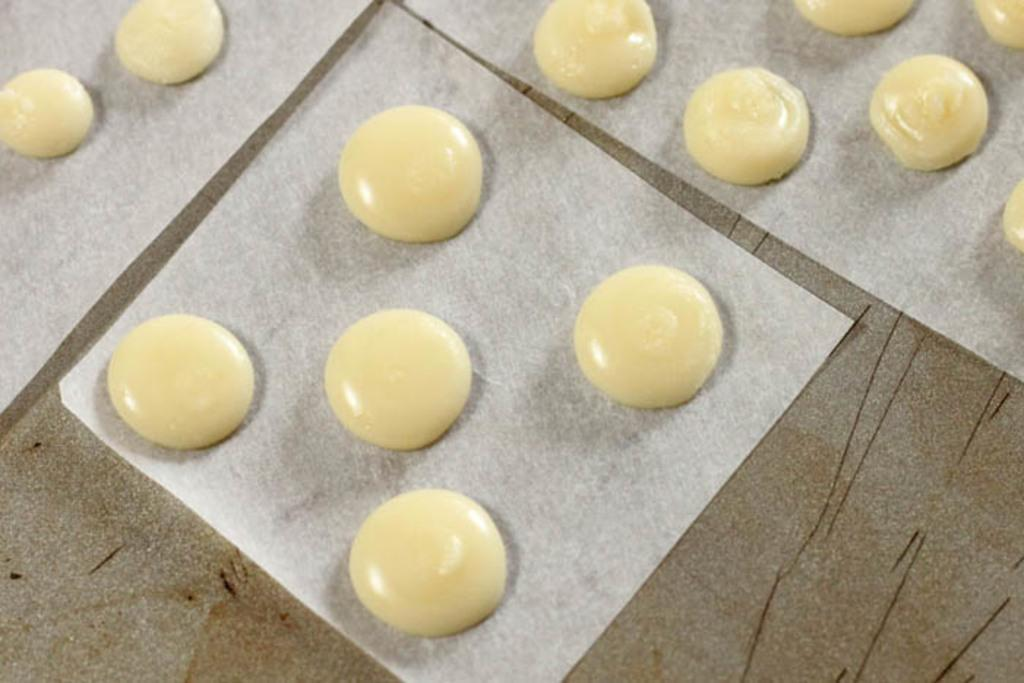What types of items can be seen in the image? There are food items in the image. What color are the objects that the food items are placed on? The objects are white colored. Where are the white colored objects located? The white colored objects are placed on a surface. Can you tell me how many yaks are present in the image? There are no yaks present in the image; it features food items on white colored objects. Is there a mitten visible in the image? There is no mitten present in the image. 